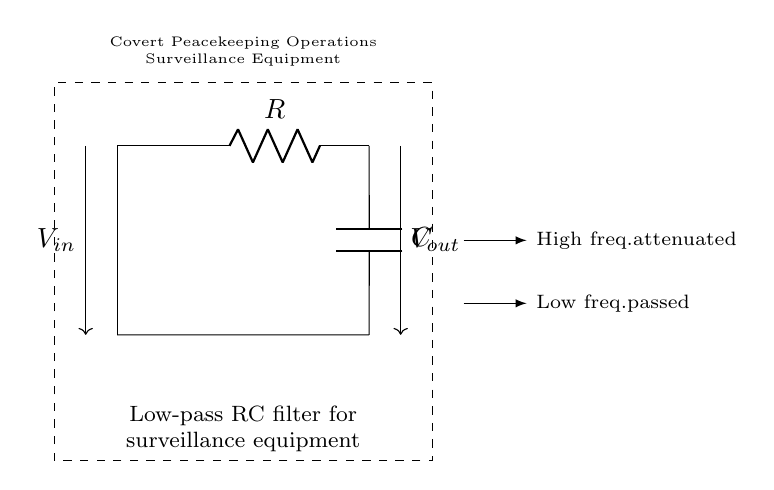What type of filter is shown in the circuit? The circuit diagram depicts a low-pass filter, as indicated by the labeling. A low-pass filter allows signals with a frequency lower than a certain cutoff frequency to pass through while attenuating higher frequency signals.
Answer: Low-pass filter What are the main components in this circuit? The primary components of the circuit are a resistor and a capacitor, which are used together to create the low-pass filter effect. These components affect how the circuit responds to different frequencies.
Answer: Resistor and capacitor What does the voltage input symbol indicate? The voltage input symbol represents the input voltage to the circuit, which is the voltage that will be filtered by the low-pass filter. It shows from where the signal originates before being processed by the circuit.
Answer: Voltage in What happens to high-frequency signals in this circuit? High-frequency signals are attenuated, meaning they are weakened or reduced in amplitude when passing through the low-pass filter. This is crucial for surveillance equipment, as it helps eliminate unwanted noise from the signal.
Answer: Attenuated What effect does the capacitor have in this circuit? The capacitor stores and releases electrical energy, which is essential for filtering. It allows low-frequency signals to pass while blocking higher frequency signals, thus playing a crucial role in the filter's function.
Answer: Filtering Which direction does the output voltage flow? The output voltage flows from the output terminal, which is positioned to the right of the circuit diagram, where the processed signal exits the filter and is sent to the next stage of the surveillance equipment.
Answer: Right What is the significance of the dashed rectangle around the circuit? The dashed rectangle groups the components of the low-pass RC filter together and labels it as part of the surveillance equipment used for covert peacekeeping operations, indicating the context of use for this circuit.
Answer: Covert peacekeeping operations 